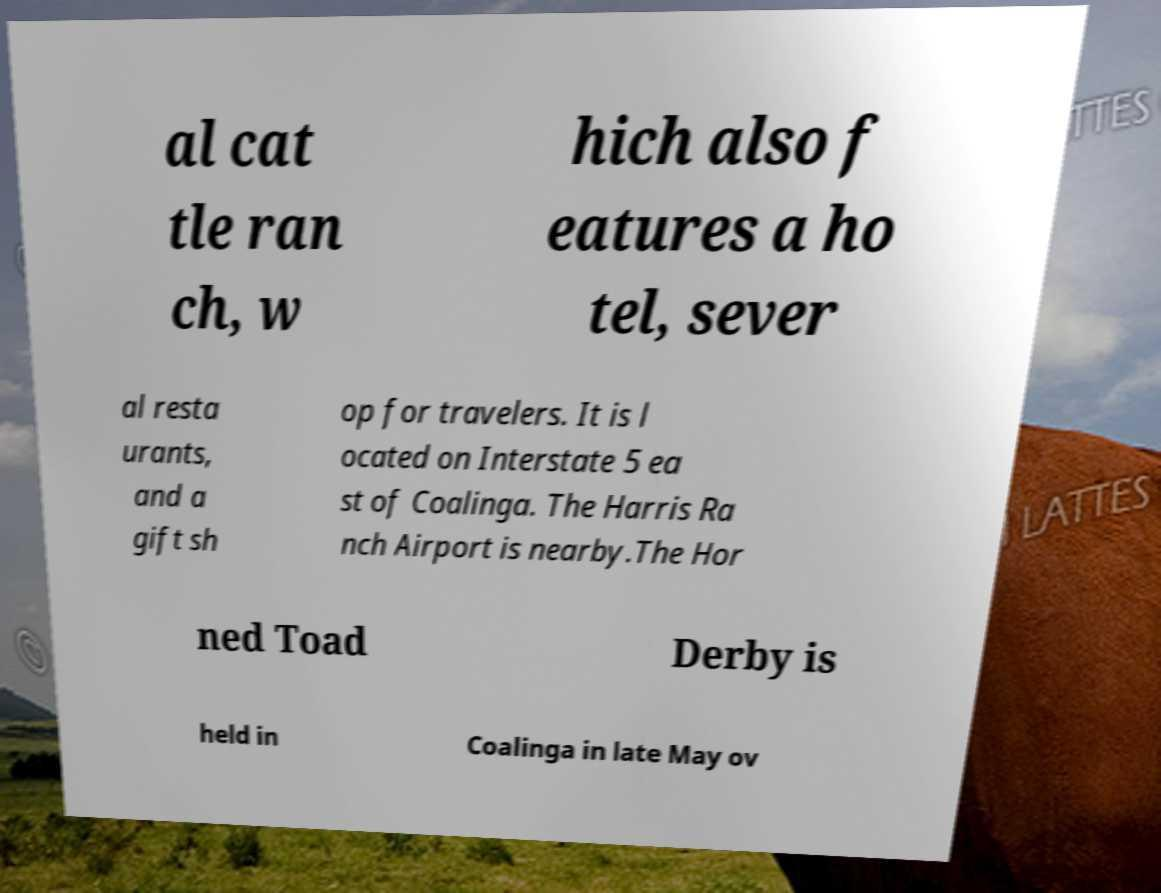I need the written content from this picture converted into text. Can you do that? al cat tle ran ch, w hich also f eatures a ho tel, sever al resta urants, and a gift sh op for travelers. It is l ocated on Interstate 5 ea st of Coalinga. The Harris Ra nch Airport is nearby.The Hor ned Toad Derby is held in Coalinga in late May ov 